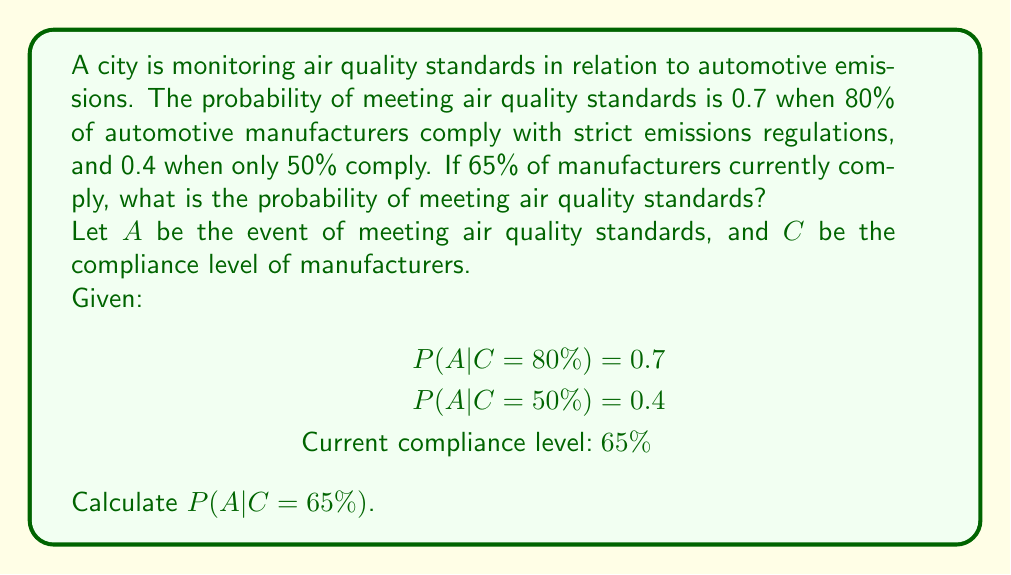Provide a solution to this math problem. To solve this problem, we'll use linear interpolation between the two known conditional probabilities.

Step 1: Identify the range of compliance levels.
Lower bound: 50%
Upper bound: 80%
Range: 80% - 50% = 30%

Step 2: Calculate the position of 65% compliance within this range.
(65% - 50%) / (80% - 50%) = 15% / 30% = 0.5

Step 3: Interpolate the probability of meeting air quality standards.
Let x be the probability we're seeking.
$$x = P(A|C=50%) + 0.5 * [P(A|C=80%) - P(A|C=50%)]$$
$$x = 0.4 + 0.5 * (0.7 - 0.4)$$
$$x = 0.4 + 0.5 * 0.3$$
$$x = 0.4 + 0.15$$
$$x = 0.55$$

Therefore, the probability of meeting air quality standards when 65% of manufacturers comply is 0.55 or 55%.
Answer: 0.55 